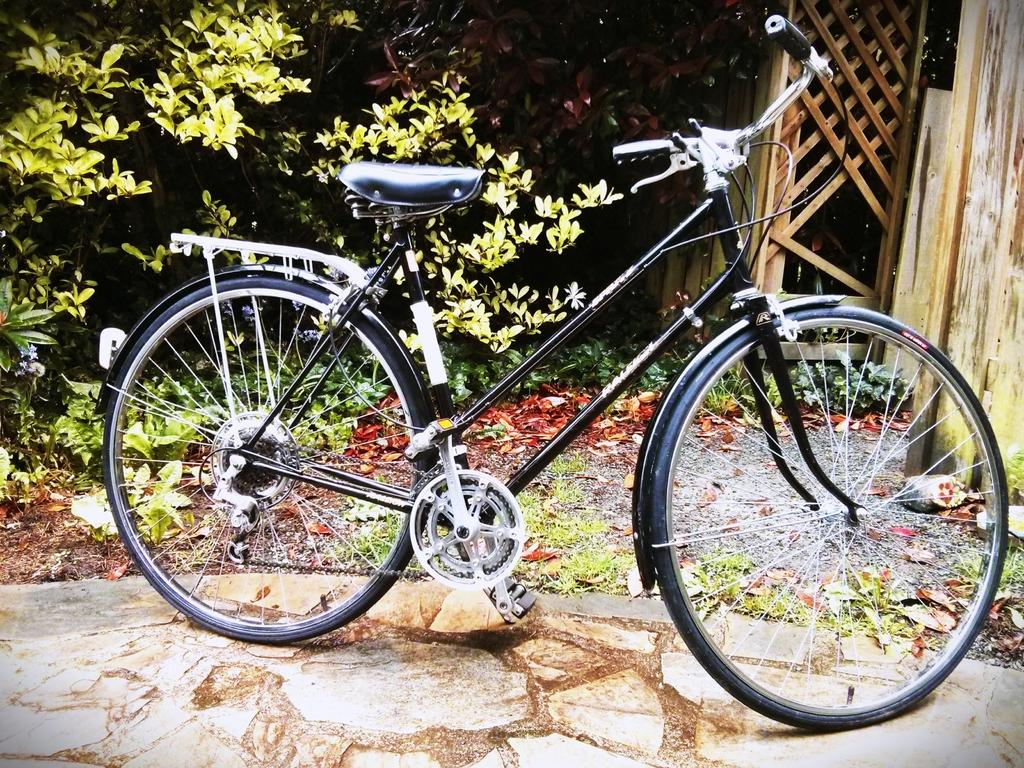Where was the picture taken? The picture was clicked outside. What can be seen in the image besides the outdoor setting? There is a black color bicycle in the image. How is the bicycle positioned in the image? The bicycle is parked on the ground. What can be seen in the background of the image? There are wooden planks, dry leaves, and plants in the background of the image. Can you see the guitar being played by someone in the image? There is no guitar or anyone playing it in the image. What type of weather can be inferred from the image? The image does not provide any information about the weather, as it only shows a parked bicycle and the background elements. 